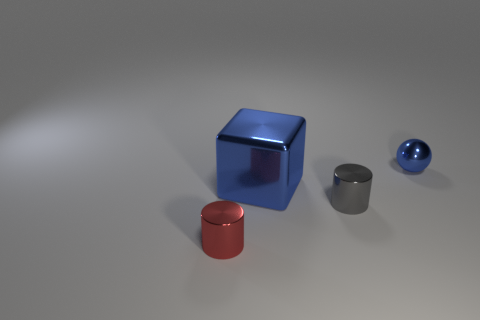There is a shiny sphere; does it have the same color as the cube on the left side of the small gray metallic cylinder?
Make the answer very short. Yes. There is a shiny thing that is behind the big block; is its color the same as the big metal thing behind the small gray cylinder?
Your response must be concise. Yes. What size is the blue shiny thing that is on the left side of the small shiny cylinder that is right of the blue metallic thing in front of the tiny blue sphere?
Keep it short and to the point. Large. What is the color of the other metal object that is the same shape as the small gray object?
Your answer should be compact. Red. Is the number of blue objects that are behind the gray metallic thing greater than the number of tiny gray things?
Keep it short and to the point. Yes. There is a gray object; is its shape the same as the small metallic object that is left of the large thing?
Offer a very short reply. Yes. Are there any other things that are the same size as the metallic cube?
Provide a succinct answer. No. The red thing that is the same shape as the gray thing is what size?
Offer a very short reply. Small. Is the number of large metal blocks greater than the number of small red balls?
Provide a succinct answer. Yes. Do the gray metallic object and the tiny red object have the same shape?
Keep it short and to the point. Yes. 